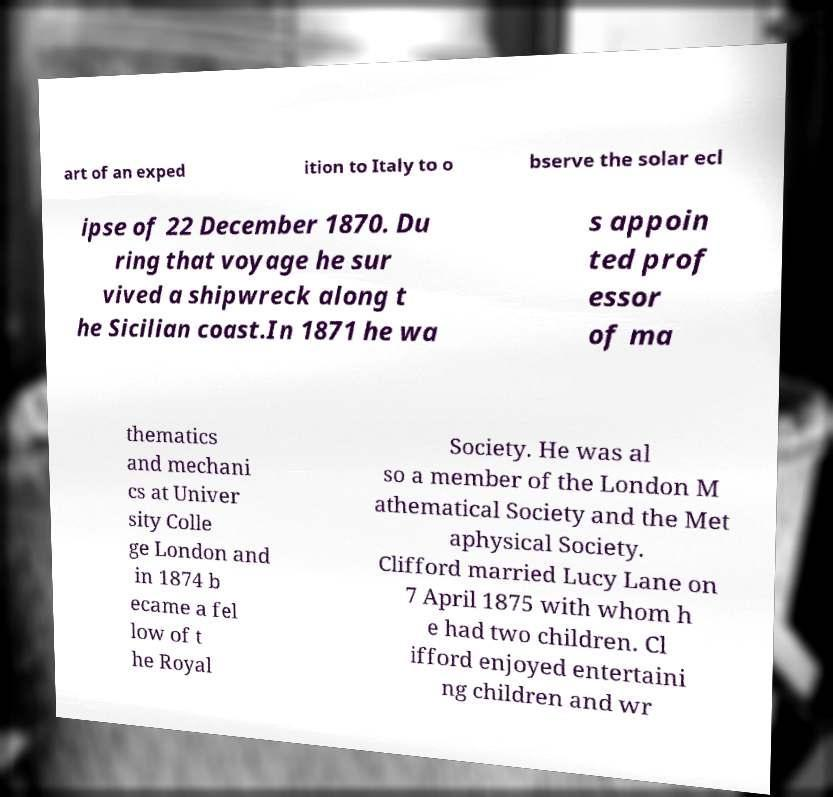Can you read and provide the text displayed in the image?This photo seems to have some interesting text. Can you extract and type it out for me? art of an exped ition to Italy to o bserve the solar ecl ipse of 22 December 1870. Du ring that voyage he sur vived a shipwreck along t he Sicilian coast.In 1871 he wa s appoin ted prof essor of ma thematics and mechani cs at Univer sity Colle ge London and in 1874 b ecame a fel low of t he Royal Society. He was al so a member of the London M athematical Society and the Met aphysical Society. Clifford married Lucy Lane on 7 April 1875 with whom h e had two children. Cl ifford enjoyed entertaini ng children and wr 